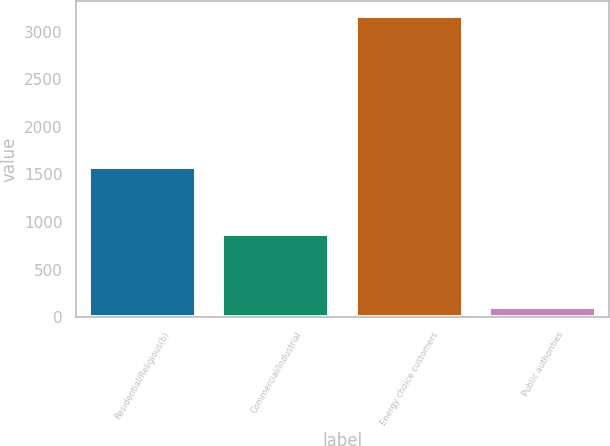Convert chart. <chart><loc_0><loc_0><loc_500><loc_500><bar_chart><fcel>Residential/Religious(b)<fcel>Commercial/Industrial<fcel>Energy choice customers<fcel>Public authorities<nl><fcel>1580<fcel>871<fcel>3166<fcel>104<nl></chart> 